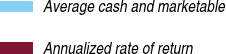Convert chart to OTSL. <chart><loc_0><loc_0><loc_500><loc_500><pie_chart><fcel>Average cash and marketable<fcel>Annualized rate of return<nl><fcel>100.0%<fcel>0.0%<nl></chart> 